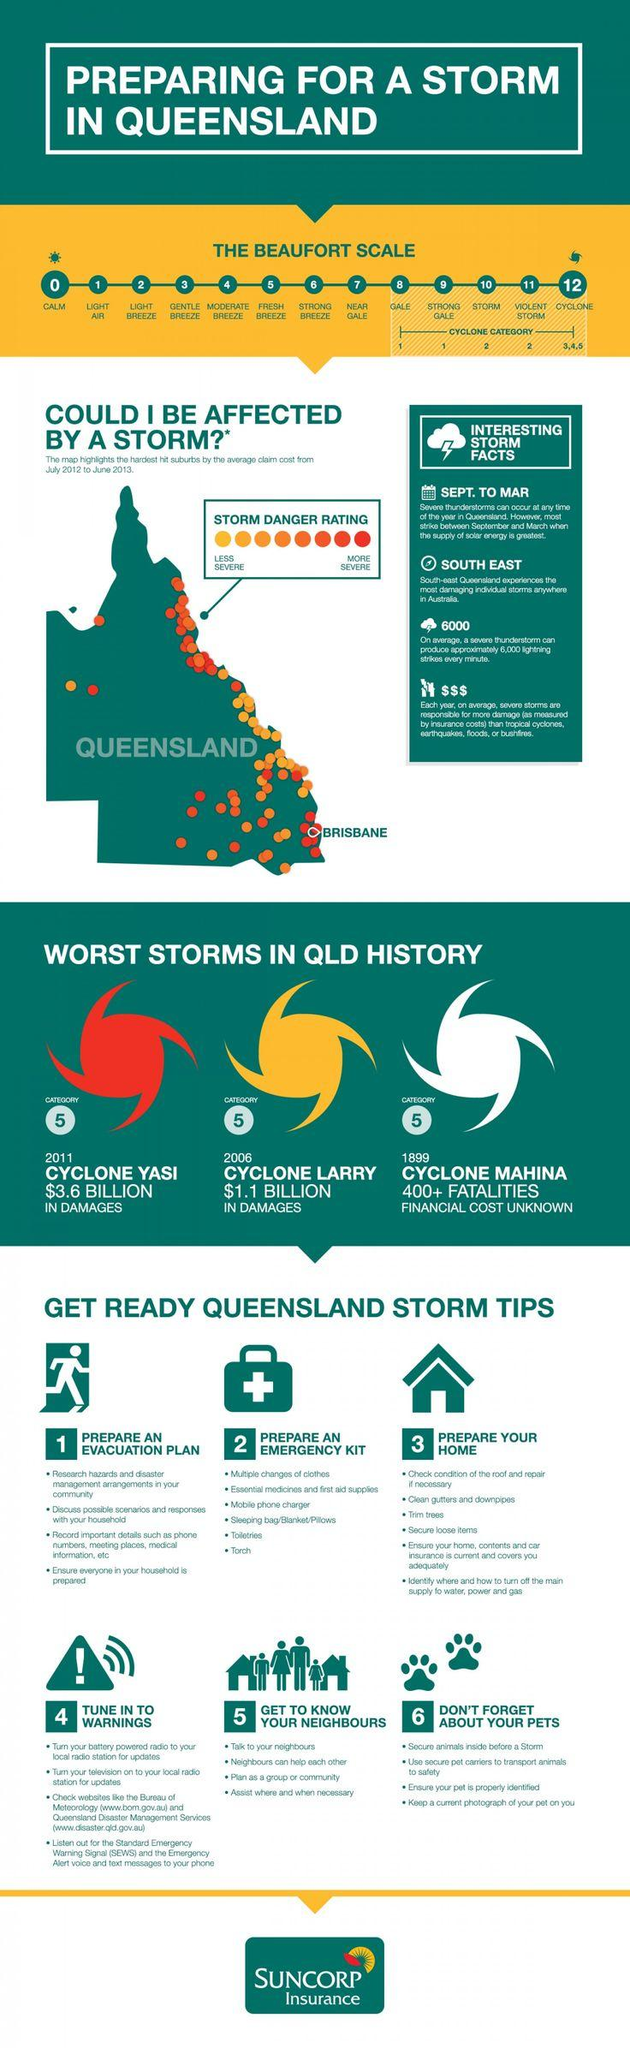Outline some significant characteristics in this image. Cyclone Larry, which resulted in $1.1 billion in damages, was a severe storm that occurred in Australia. The financial cost of the storm currently being referred to as Cyclone Mahina is unknown, as the full extent of the damage is still being assessed. Cyclone Mahina occurred in 1899. A gale is considered the beginning of a cyclone category. In the year 2011, Cyclone Yasi occurred. 